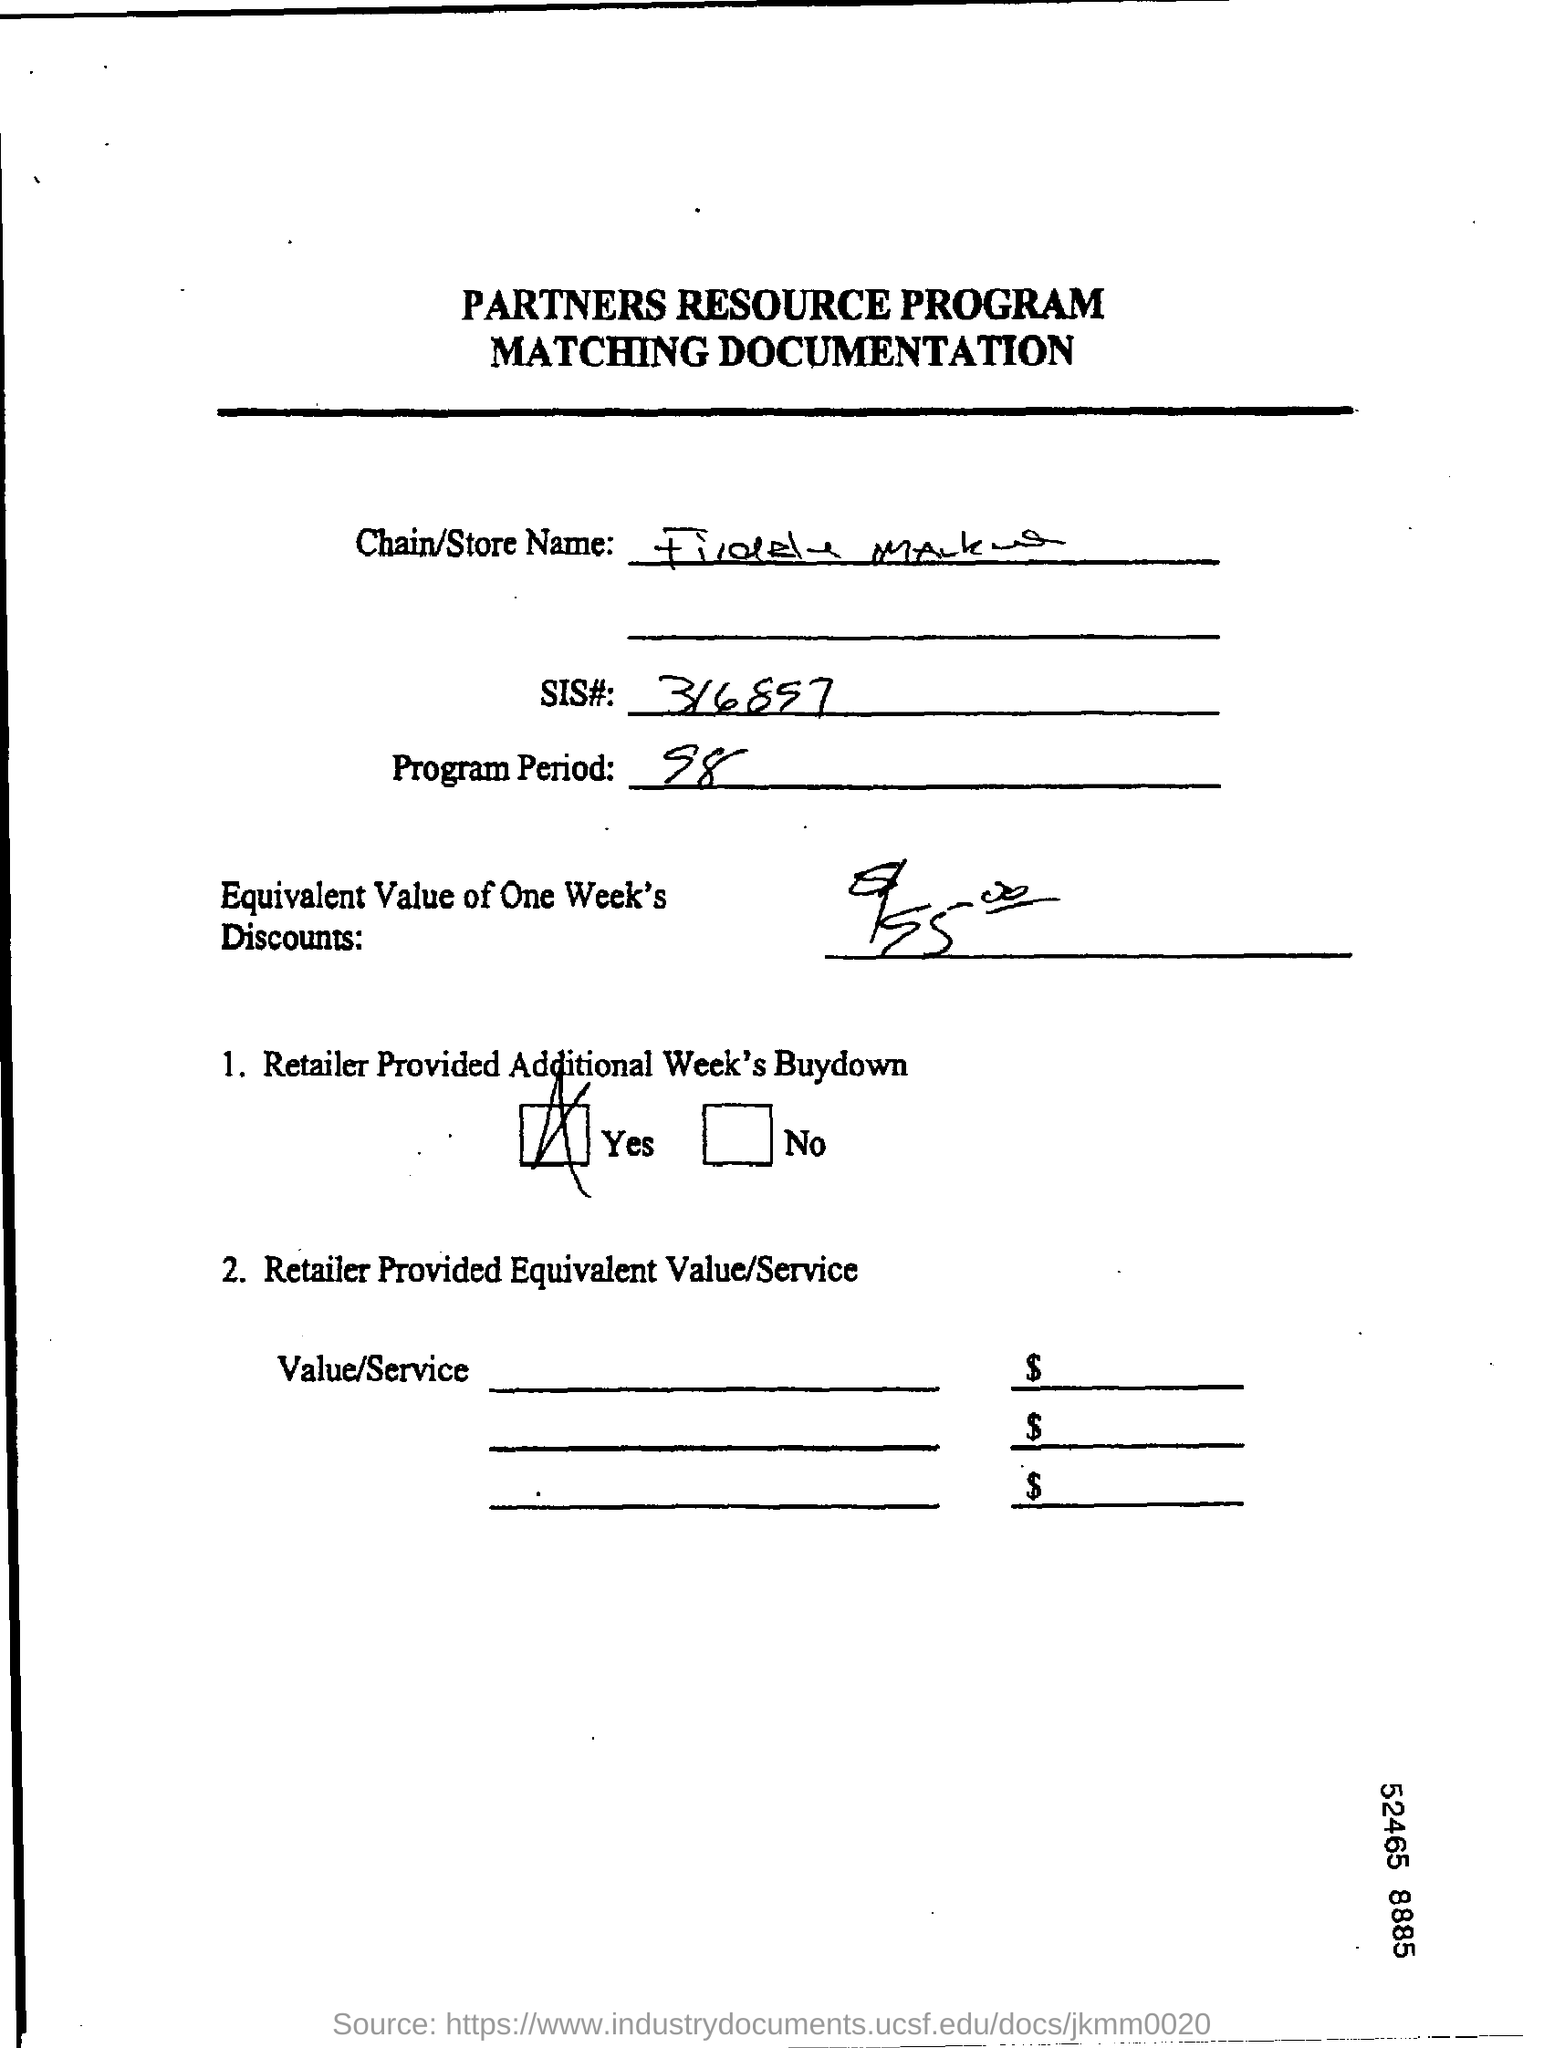What is the SIS#?
Keep it short and to the point. 316897. What is the program period?
Your response must be concise. 98. 